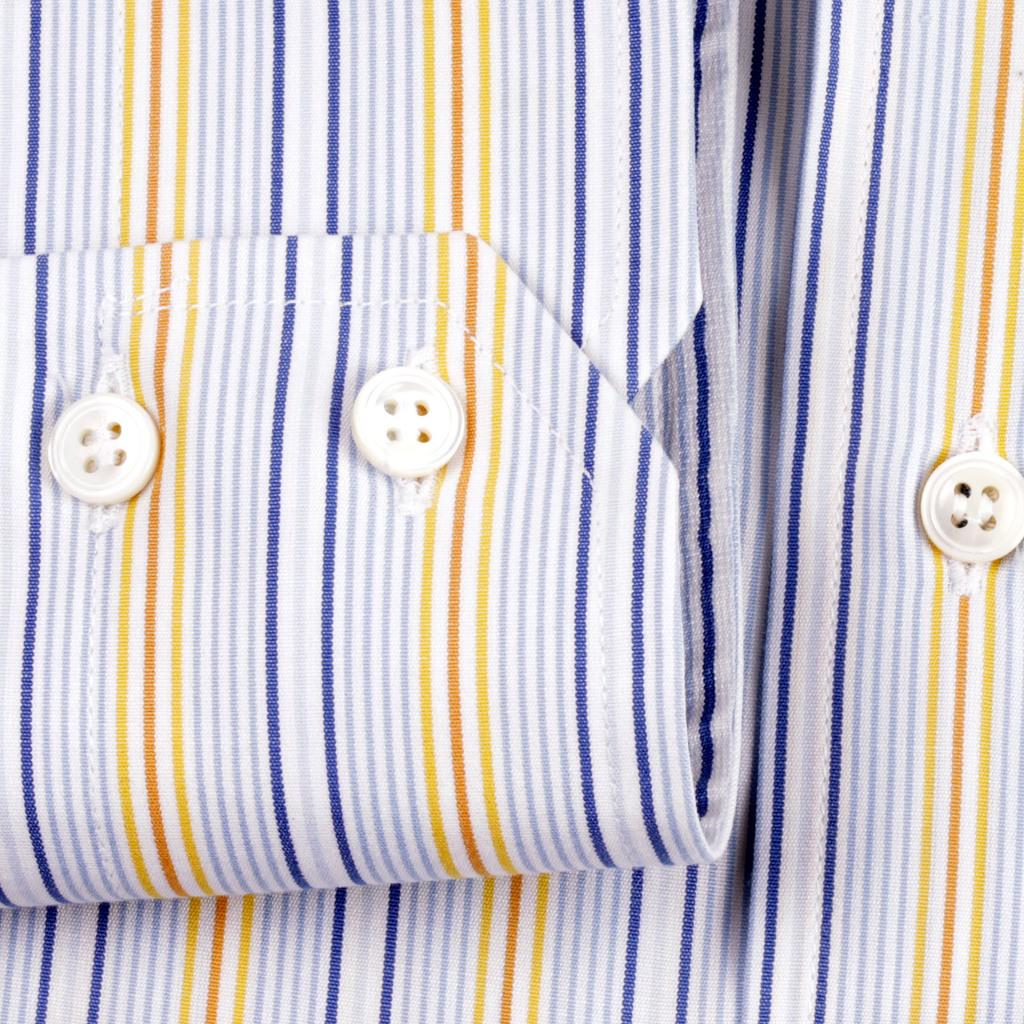What type of clothing item is featured in the image? There are buttons on a shirt in the image. Can you describe the buttons on the shirt? The buttons on the shirt are visible in the image. What type of pets can be seen playing with the buttons on the shirt in the image? There are no pets present in the image, and therefore no such activity can be observed. What type of base is supporting the shirt in the image? The image does not show any base supporting the shirt; it only shows the shirt with buttons. 